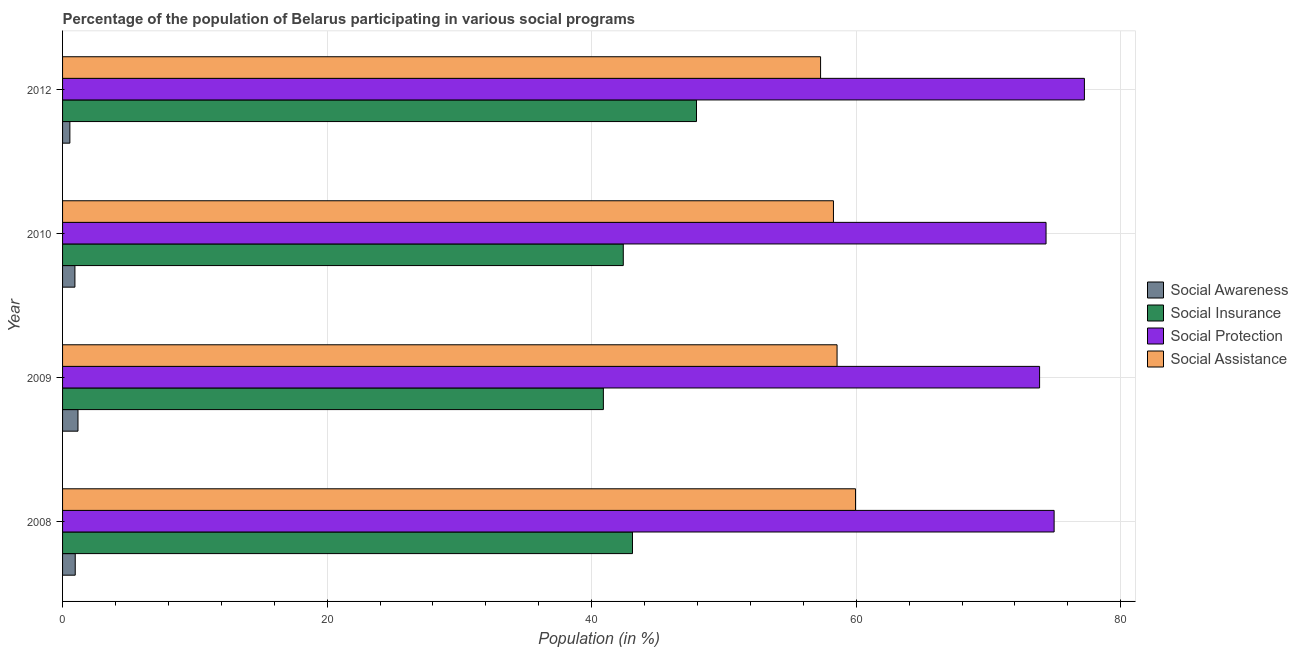What is the label of the 2nd group of bars from the top?
Ensure brevity in your answer.  2010. What is the participation of population in social assistance programs in 2012?
Your answer should be very brief. 57.3. Across all years, what is the maximum participation of population in social protection programs?
Ensure brevity in your answer.  77.25. Across all years, what is the minimum participation of population in social protection programs?
Provide a succinct answer. 73.86. In which year was the participation of population in social awareness programs maximum?
Offer a very short reply. 2009. What is the total participation of population in social insurance programs in the graph?
Your answer should be very brief. 174.29. What is the difference between the participation of population in social awareness programs in 2010 and that in 2012?
Your answer should be compact. 0.38. What is the difference between the participation of population in social assistance programs in 2010 and the participation of population in social insurance programs in 2009?
Ensure brevity in your answer.  17.39. What is the average participation of population in social assistance programs per year?
Provide a succinct answer. 58.52. In the year 2010, what is the difference between the participation of population in social assistance programs and participation of population in social protection programs?
Offer a very short reply. -16.07. In how many years, is the participation of population in social insurance programs greater than 68 %?
Offer a very short reply. 0. What is the ratio of the participation of population in social assistance programs in 2008 to that in 2009?
Give a very brief answer. 1.02. Is the difference between the participation of population in social insurance programs in 2008 and 2012 greater than the difference between the participation of population in social protection programs in 2008 and 2012?
Your response must be concise. No. What is the difference between the highest and the second highest participation of population in social assistance programs?
Provide a succinct answer. 1.4. What is the difference between the highest and the lowest participation of population in social assistance programs?
Offer a very short reply. 2.64. In how many years, is the participation of population in social protection programs greater than the average participation of population in social protection programs taken over all years?
Give a very brief answer. 1. What does the 4th bar from the top in 2009 represents?
Keep it short and to the point. Social Awareness. What does the 3rd bar from the bottom in 2008 represents?
Make the answer very short. Social Protection. Is it the case that in every year, the sum of the participation of population in social awareness programs and participation of population in social insurance programs is greater than the participation of population in social protection programs?
Give a very brief answer. No. How many bars are there?
Offer a terse response. 16. Are all the bars in the graph horizontal?
Ensure brevity in your answer.  Yes. Are the values on the major ticks of X-axis written in scientific E-notation?
Make the answer very short. No. Does the graph contain grids?
Your response must be concise. Yes. Where does the legend appear in the graph?
Offer a very short reply. Center right. How many legend labels are there?
Ensure brevity in your answer.  4. How are the legend labels stacked?
Your response must be concise. Vertical. What is the title of the graph?
Your answer should be compact. Percentage of the population of Belarus participating in various social programs . What is the label or title of the X-axis?
Ensure brevity in your answer.  Population (in %). What is the label or title of the Y-axis?
Provide a succinct answer. Year. What is the Population (in %) of Social Awareness in 2008?
Give a very brief answer. 0.96. What is the Population (in %) of Social Insurance in 2008?
Keep it short and to the point. 43.09. What is the Population (in %) in Social Protection in 2008?
Make the answer very short. 74.96. What is the Population (in %) in Social Assistance in 2008?
Ensure brevity in your answer.  59.95. What is the Population (in %) of Social Awareness in 2009?
Ensure brevity in your answer.  1.17. What is the Population (in %) in Social Insurance in 2009?
Your response must be concise. 40.89. What is the Population (in %) of Social Protection in 2009?
Make the answer very short. 73.86. What is the Population (in %) in Social Assistance in 2009?
Your answer should be very brief. 58.55. What is the Population (in %) in Social Awareness in 2010?
Ensure brevity in your answer.  0.93. What is the Population (in %) of Social Insurance in 2010?
Offer a terse response. 42.39. What is the Population (in %) in Social Protection in 2010?
Offer a very short reply. 74.35. What is the Population (in %) of Social Assistance in 2010?
Offer a very short reply. 58.28. What is the Population (in %) of Social Awareness in 2012?
Keep it short and to the point. 0.55. What is the Population (in %) in Social Insurance in 2012?
Keep it short and to the point. 47.93. What is the Population (in %) in Social Protection in 2012?
Your response must be concise. 77.25. What is the Population (in %) of Social Assistance in 2012?
Offer a terse response. 57.3. Across all years, what is the maximum Population (in %) in Social Awareness?
Provide a short and direct response. 1.17. Across all years, what is the maximum Population (in %) in Social Insurance?
Give a very brief answer. 47.93. Across all years, what is the maximum Population (in %) of Social Protection?
Your response must be concise. 77.25. Across all years, what is the maximum Population (in %) of Social Assistance?
Ensure brevity in your answer.  59.95. Across all years, what is the minimum Population (in %) in Social Awareness?
Keep it short and to the point. 0.55. Across all years, what is the minimum Population (in %) in Social Insurance?
Your answer should be very brief. 40.89. Across all years, what is the minimum Population (in %) of Social Protection?
Your answer should be very brief. 73.86. Across all years, what is the minimum Population (in %) in Social Assistance?
Your response must be concise. 57.3. What is the total Population (in %) of Social Awareness in the graph?
Ensure brevity in your answer.  3.61. What is the total Population (in %) of Social Insurance in the graph?
Give a very brief answer. 174.29. What is the total Population (in %) of Social Protection in the graph?
Give a very brief answer. 300.42. What is the total Population (in %) of Social Assistance in the graph?
Give a very brief answer. 234.08. What is the difference between the Population (in %) in Social Awareness in 2008 and that in 2009?
Offer a terse response. -0.21. What is the difference between the Population (in %) of Social Insurance in 2008 and that in 2009?
Provide a short and direct response. 2.2. What is the difference between the Population (in %) in Social Protection in 2008 and that in 2009?
Keep it short and to the point. 1.1. What is the difference between the Population (in %) of Social Assistance in 2008 and that in 2009?
Offer a very short reply. 1.4. What is the difference between the Population (in %) of Social Awareness in 2008 and that in 2010?
Make the answer very short. 0.02. What is the difference between the Population (in %) of Social Insurance in 2008 and that in 2010?
Provide a short and direct response. 0.7. What is the difference between the Population (in %) of Social Protection in 2008 and that in 2010?
Your answer should be very brief. 0.61. What is the difference between the Population (in %) in Social Assistance in 2008 and that in 2010?
Keep it short and to the point. 1.67. What is the difference between the Population (in %) in Social Awareness in 2008 and that in 2012?
Your answer should be compact. 0.4. What is the difference between the Population (in %) in Social Insurance in 2008 and that in 2012?
Your answer should be compact. -4.84. What is the difference between the Population (in %) in Social Protection in 2008 and that in 2012?
Offer a terse response. -2.29. What is the difference between the Population (in %) of Social Assistance in 2008 and that in 2012?
Offer a terse response. 2.64. What is the difference between the Population (in %) of Social Awareness in 2009 and that in 2010?
Ensure brevity in your answer.  0.23. What is the difference between the Population (in %) of Social Insurance in 2009 and that in 2010?
Offer a very short reply. -1.5. What is the difference between the Population (in %) of Social Protection in 2009 and that in 2010?
Keep it short and to the point. -0.49. What is the difference between the Population (in %) of Social Assistance in 2009 and that in 2010?
Your answer should be compact. 0.27. What is the difference between the Population (in %) in Social Awareness in 2009 and that in 2012?
Provide a short and direct response. 0.61. What is the difference between the Population (in %) in Social Insurance in 2009 and that in 2012?
Make the answer very short. -7.04. What is the difference between the Population (in %) in Social Protection in 2009 and that in 2012?
Offer a terse response. -3.39. What is the difference between the Population (in %) of Social Assistance in 2009 and that in 2012?
Provide a short and direct response. 1.25. What is the difference between the Population (in %) in Social Awareness in 2010 and that in 2012?
Offer a very short reply. 0.38. What is the difference between the Population (in %) in Social Insurance in 2010 and that in 2012?
Ensure brevity in your answer.  -5.54. What is the difference between the Population (in %) of Social Protection in 2010 and that in 2012?
Give a very brief answer. -2.9. What is the difference between the Population (in %) of Social Assistance in 2010 and that in 2012?
Keep it short and to the point. 0.97. What is the difference between the Population (in %) in Social Awareness in 2008 and the Population (in %) in Social Insurance in 2009?
Keep it short and to the point. -39.93. What is the difference between the Population (in %) in Social Awareness in 2008 and the Population (in %) in Social Protection in 2009?
Your response must be concise. -72.9. What is the difference between the Population (in %) of Social Awareness in 2008 and the Population (in %) of Social Assistance in 2009?
Make the answer very short. -57.59. What is the difference between the Population (in %) of Social Insurance in 2008 and the Population (in %) of Social Protection in 2009?
Provide a succinct answer. -30.78. What is the difference between the Population (in %) of Social Insurance in 2008 and the Population (in %) of Social Assistance in 2009?
Offer a terse response. -15.47. What is the difference between the Population (in %) in Social Protection in 2008 and the Population (in %) in Social Assistance in 2009?
Give a very brief answer. 16.41. What is the difference between the Population (in %) in Social Awareness in 2008 and the Population (in %) in Social Insurance in 2010?
Provide a short and direct response. -41.43. What is the difference between the Population (in %) in Social Awareness in 2008 and the Population (in %) in Social Protection in 2010?
Your answer should be very brief. -73.39. What is the difference between the Population (in %) in Social Awareness in 2008 and the Population (in %) in Social Assistance in 2010?
Provide a succinct answer. -57.32. What is the difference between the Population (in %) in Social Insurance in 2008 and the Population (in %) in Social Protection in 2010?
Provide a short and direct response. -31.26. What is the difference between the Population (in %) in Social Insurance in 2008 and the Population (in %) in Social Assistance in 2010?
Offer a very short reply. -15.19. What is the difference between the Population (in %) of Social Protection in 2008 and the Population (in %) of Social Assistance in 2010?
Provide a succinct answer. 16.68. What is the difference between the Population (in %) in Social Awareness in 2008 and the Population (in %) in Social Insurance in 2012?
Offer a very short reply. -46.97. What is the difference between the Population (in %) in Social Awareness in 2008 and the Population (in %) in Social Protection in 2012?
Provide a succinct answer. -76.29. What is the difference between the Population (in %) in Social Awareness in 2008 and the Population (in %) in Social Assistance in 2012?
Provide a succinct answer. -56.35. What is the difference between the Population (in %) in Social Insurance in 2008 and the Population (in %) in Social Protection in 2012?
Your answer should be very brief. -34.16. What is the difference between the Population (in %) in Social Insurance in 2008 and the Population (in %) in Social Assistance in 2012?
Your answer should be compact. -14.22. What is the difference between the Population (in %) in Social Protection in 2008 and the Population (in %) in Social Assistance in 2012?
Your answer should be compact. 17.66. What is the difference between the Population (in %) of Social Awareness in 2009 and the Population (in %) of Social Insurance in 2010?
Provide a short and direct response. -41.22. What is the difference between the Population (in %) of Social Awareness in 2009 and the Population (in %) of Social Protection in 2010?
Offer a terse response. -73.18. What is the difference between the Population (in %) in Social Awareness in 2009 and the Population (in %) in Social Assistance in 2010?
Your answer should be compact. -57.11. What is the difference between the Population (in %) in Social Insurance in 2009 and the Population (in %) in Social Protection in 2010?
Your answer should be compact. -33.47. What is the difference between the Population (in %) of Social Insurance in 2009 and the Population (in %) of Social Assistance in 2010?
Keep it short and to the point. -17.39. What is the difference between the Population (in %) of Social Protection in 2009 and the Population (in %) of Social Assistance in 2010?
Provide a succinct answer. 15.58. What is the difference between the Population (in %) in Social Awareness in 2009 and the Population (in %) in Social Insurance in 2012?
Your answer should be compact. -46.76. What is the difference between the Population (in %) of Social Awareness in 2009 and the Population (in %) of Social Protection in 2012?
Give a very brief answer. -76.08. What is the difference between the Population (in %) in Social Awareness in 2009 and the Population (in %) in Social Assistance in 2012?
Make the answer very short. -56.14. What is the difference between the Population (in %) in Social Insurance in 2009 and the Population (in %) in Social Protection in 2012?
Offer a terse response. -36.37. What is the difference between the Population (in %) in Social Insurance in 2009 and the Population (in %) in Social Assistance in 2012?
Provide a succinct answer. -16.42. What is the difference between the Population (in %) in Social Protection in 2009 and the Population (in %) in Social Assistance in 2012?
Your response must be concise. 16.56. What is the difference between the Population (in %) of Social Awareness in 2010 and the Population (in %) of Social Insurance in 2012?
Provide a short and direct response. -46.99. What is the difference between the Population (in %) of Social Awareness in 2010 and the Population (in %) of Social Protection in 2012?
Ensure brevity in your answer.  -76.32. What is the difference between the Population (in %) in Social Awareness in 2010 and the Population (in %) in Social Assistance in 2012?
Make the answer very short. -56.37. What is the difference between the Population (in %) in Social Insurance in 2010 and the Population (in %) in Social Protection in 2012?
Your response must be concise. -34.86. What is the difference between the Population (in %) in Social Insurance in 2010 and the Population (in %) in Social Assistance in 2012?
Keep it short and to the point. -14.92. What is the difference between the Population (in %) of Social Protection in 2010 and the Population (in %) of Social Assistance in 2012?
Ensure brevity in your answer.  17.05. What is the average Population (in %) of Social Awareness per year?
Ensure brevity in your answer.  0.9. What is the average Population (in %) in Social Insurance per year?
Give a very brief answer. 43.57. What is the average Population (in %) in Social Protection per year?
Your answer should be compact. 75.11. What is the average Population (in %) of Social Assistance per year?
Your answer should be compact. 58.52. In the year 2008, what is the difference between the Population (in %) in Social Awareness and Population (in %) in Social Insurance?
Make the answer very short. -42.13. In the year 2008, what is the difference between the Population (in %) of Social Awareness and Population (in %) of Social Protection?
Provide a succinct answer. -74. In the year 2008, what is the difference between the Population (in %) of Social Awareness and Population (in %) of Social Assistance?
Provide a short and direct response. -58.99. In the year 2008, what is the difference between the Population (in %) of Social Insurance and Population (in %) of Social Protection?
Your answer should be compact. -31.88. In the year 2008, what is the difference between the Population (in %) in Social Insurance and Population (in %) in Social Assistance?
Offer a very short reply. -16.86. In the year 2008, what is the difference between the Population (in %) in Social Protection and Population (in %) in Social Assistance?
Provide a succinct answer. 15.01. In the year 2009, what is the difference between the Population (in %) of Social Awareness and Population (in %) of Social Insurance?
Provide a short and direct response. -39.72. In the year 2009, what is the difference between the Population (in %) of Social Awareness and Population (in %) of Social Protection?
Give a very brief answer. -72.7. In the year 2009, what is the difference between the Population (in %) in Social Awareness and Population (in %) in Social Assistance?
Give a very brief answer. -57.39. In the year 2009, what is the difference between the Population (in %) in Social Insurance and Population (in %) in Social Protection?
Keep it short and to the point. -32.98. In the year 2009, what is the difference between the Population (in %) in Social Insurance and Population (in %) in Social Assistance?
Your answer should be very brief. -17.67. In the year 2009, what is the difference between the Population (in %) in Social Protection and Population (in %) in Social Assistance?
Keep it short and to the point. 15.31. In the year 2010, what is the difference between the Population (in %) in Social Awareness and Population (in %) in Social Insurance?
Your response must be concise. -41.46. In the year 2010, what is the difference between the Population (in %) of Social Awareness and Population (in %) of Social Protection?
Provide a short and direct response. -73.42. In the year 2010, what is the difference between the Population (in %) of Social Awareness and Population (in %) of Social Assistance?
Ensure brevity in your answer.  -57.34. In the year 2010, what is the difference between the Population (in %) of Social Insurance and Population (in %) of Social Protection?
Make the answer very short. -31.96. In the year 2010, what is the difference between the Population (in %) in Social Insurance and Population (in %) in Social Assistance?
Your answer should be compact. -15.89. In the year 2010, what is the difference between the Population (in %) in Social Protection and Population (in %) in Social Assistance?
Ensure brevity in your answer.  16.07. In the year 2012, what is the difference between the Population (in %) of Social Awareness and Population (in %) of Social Insurance?
Your answer should be very brief. -47.37. In the year 2012, what is the difference between the Population (in %) of Social Awareness and Population (in %) of Social Protection?
Provide a succinct answer. -76.7. In the year 2012, what is the difference between the Population (in %) of Social Awareness and Population (in %) of Social Assistance?
Offer a very short reply. -56.75. In the year 2012, what is the difference between the Population (in %) of Social Insurance and Population (in %) of Social Protection?
Give a very brief answer. -29.32. In the year 2012, what is the difference between the Population (in %) of Social Insurance and Population (in %) of Social Assistance?
Provide a short and direct response. -9.38. In the year 2012, what is the difference between the Population (in %) of Social Protection and Population (in %) of Social Assistance?
Give a very brief answer. 19.95. What is the ratio of the Population (in %) of Social Awareness in 2008 to that in 2009?
Provide a short and direct response. 0.82. What is the ratio of the Population (in %) in Social Insurance in 2008 to that in 2009?
Offer a very short reply. 1.05. What is the ratio of the Population (in %) in Social Protection in 2008 to that in 2009?
Your answer should be compact. 1.01. What is the ratio of the Population (in %) of Social Assistance in 2008 to that in 2009?
Your response must be concise. 1.02. What is the ratio of the Population (in %) of Social Awareness in 2008 to that in 2010?
Make the answer very short. 1.02. What is the ratio of the Population (in %) in Social Insurance in 2008 to that in 2010?
Provide a succinct answer. 1.02. What is the ratio of the Population (in %) in Social Protection in 2008 to that in 2010?
Give a very brief answer. 1.01. What is the ratio of the Population (in %) in Social Assistance in 2008 to that in 2010?
Make the answer very short. 1.03. What is the ratio of the Population (in %) of Social Awareness in 2008 to that in 2012?
Your answer should be very brief. 1.73. What is the ratio of the Population (in %) of Social Insurance in 2008 to that in 2012?
Your answer should be very brief. 0.9. What is the ratio of the Population (in %) of Social Protection in 2008 to that in 2012?
Provide a short and direct response. 0.97. What is the ratio of the Population (in %) in Social Assistance in 2008 to that in 2012?
Your response must be concise. 1.05. What is the ratio of the Population (in %) of Social Awareness in 2009 to that in 2010?
Make the answer very short. 1.25. What is the ratio of the Population (in %) of Social Insurance in 2009 to that in 2010?
Keep it short and to the point. 0.96. What is the ratio of the Population (in %) in Social Assistance in 2009 to that in 2010?
Keep it short and to the point. 1. What is the ratio of the Population (in %) of Social Awareness in 2009 to that in 2012?
Offer a terse response. 2.11. What is the ratio of the Population (in %) of Social Insurance in 2009 to that in 2012?
Your response must be concise. 0.85. What is the ratio of the Population (in %) in Social Protection in 2009 to that in 2012?
Offer a terse response. 0.96. What is the ratio of the Population (in %) in Social Assistance in 2009 to that in 2012?
Provide a short and direct response. 1.02. What is the ratio of the Population (in %) in Social Awareness in 2010 to that in 2012?
Give a very brief answer. 1.69. What is the ratio of the Population (in %) of Social Insurance in 2010 to that in 2012?
Offer a terse response. 0.88. What is the ratio of the Population (in %) of Social Protection in 2010 to that in 2012?
Provide a succinct answer. 0.96. What is the difference between the highest and the second highest Population (in %) of Social Awareness?
Provide a short and direct response. 0.21. What is the difference between the highest and the second highest Population (in %) of Social Insurance?
Provide a succinct answer. 4.84. What is the difference between the highest and the second highest Population (in %) of Social Protection?
Provide a succinct answer. 2.29. What is the difference between the highest and the second highest Population (in %) in Social Assistance?
Make the answer very short. 1.4. What is the difference between the highest and the lowest Population (in %) in Social Awareness?
Give a very brief answer. 0.61. What is the difference between the highest and the lowest Population (in %) of Social Insurance?
Make the answer very short. 7.04. What is the difference between the highest and the lowest Population (in %) in Social Protection?
Your response must be concise. 3.39. What is the difference between the highest and the lowest Population (in %) of Social Assistance?
Ensure brevity in your answer.  2.64. 